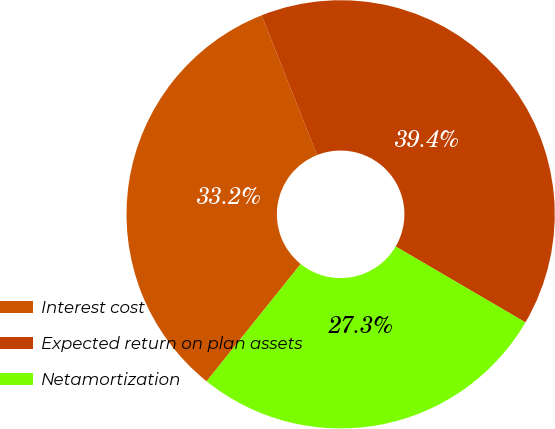Convert chart to OTSL. <chart><loc_0><loc_0><loc_500><loc_500><pie_chart><fcel>Interest cost<fcel>Expected return on plan assets<fcel>Netamortization<nl><fcel>33.22%<fcel>39.44%<fcel>27.34%<nl></chart> 